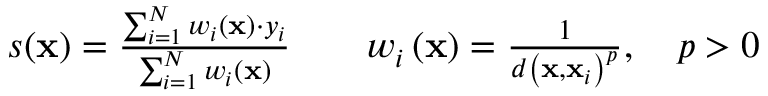<formula> <loc_0><loc_0><loc_500><loc_500>\begin{array} { r l r l } & { s ( x ) = \frac { \sum _ { i = 1 } ^ { N } w _ { i } \left ( x \right ) \cdot y _ { i } } { \sum _ { i = 1 } ^ { N } w _ { i } \left ( x \right ) } } & & { w _ { i } \left ( x \right ) = \frac { 1 } { d \left ( x , x _ { i } \right ) ^ { p } } , \quad p > 0 } \end{array}</formula> 